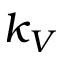Convert formula to latex. <formula><loc_0><loc_0><loc_500><loc_500>k _ { V }</formula> 